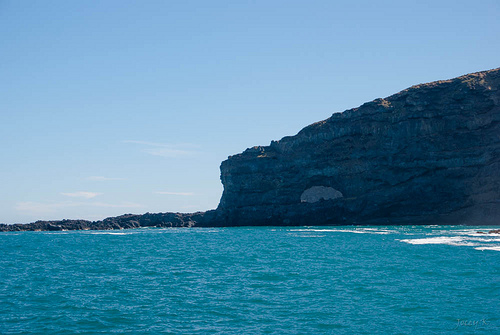<image>
Is the water under the rock? Yes. The water is positioned underneath the rock, with the rock above it in the vertical space. 